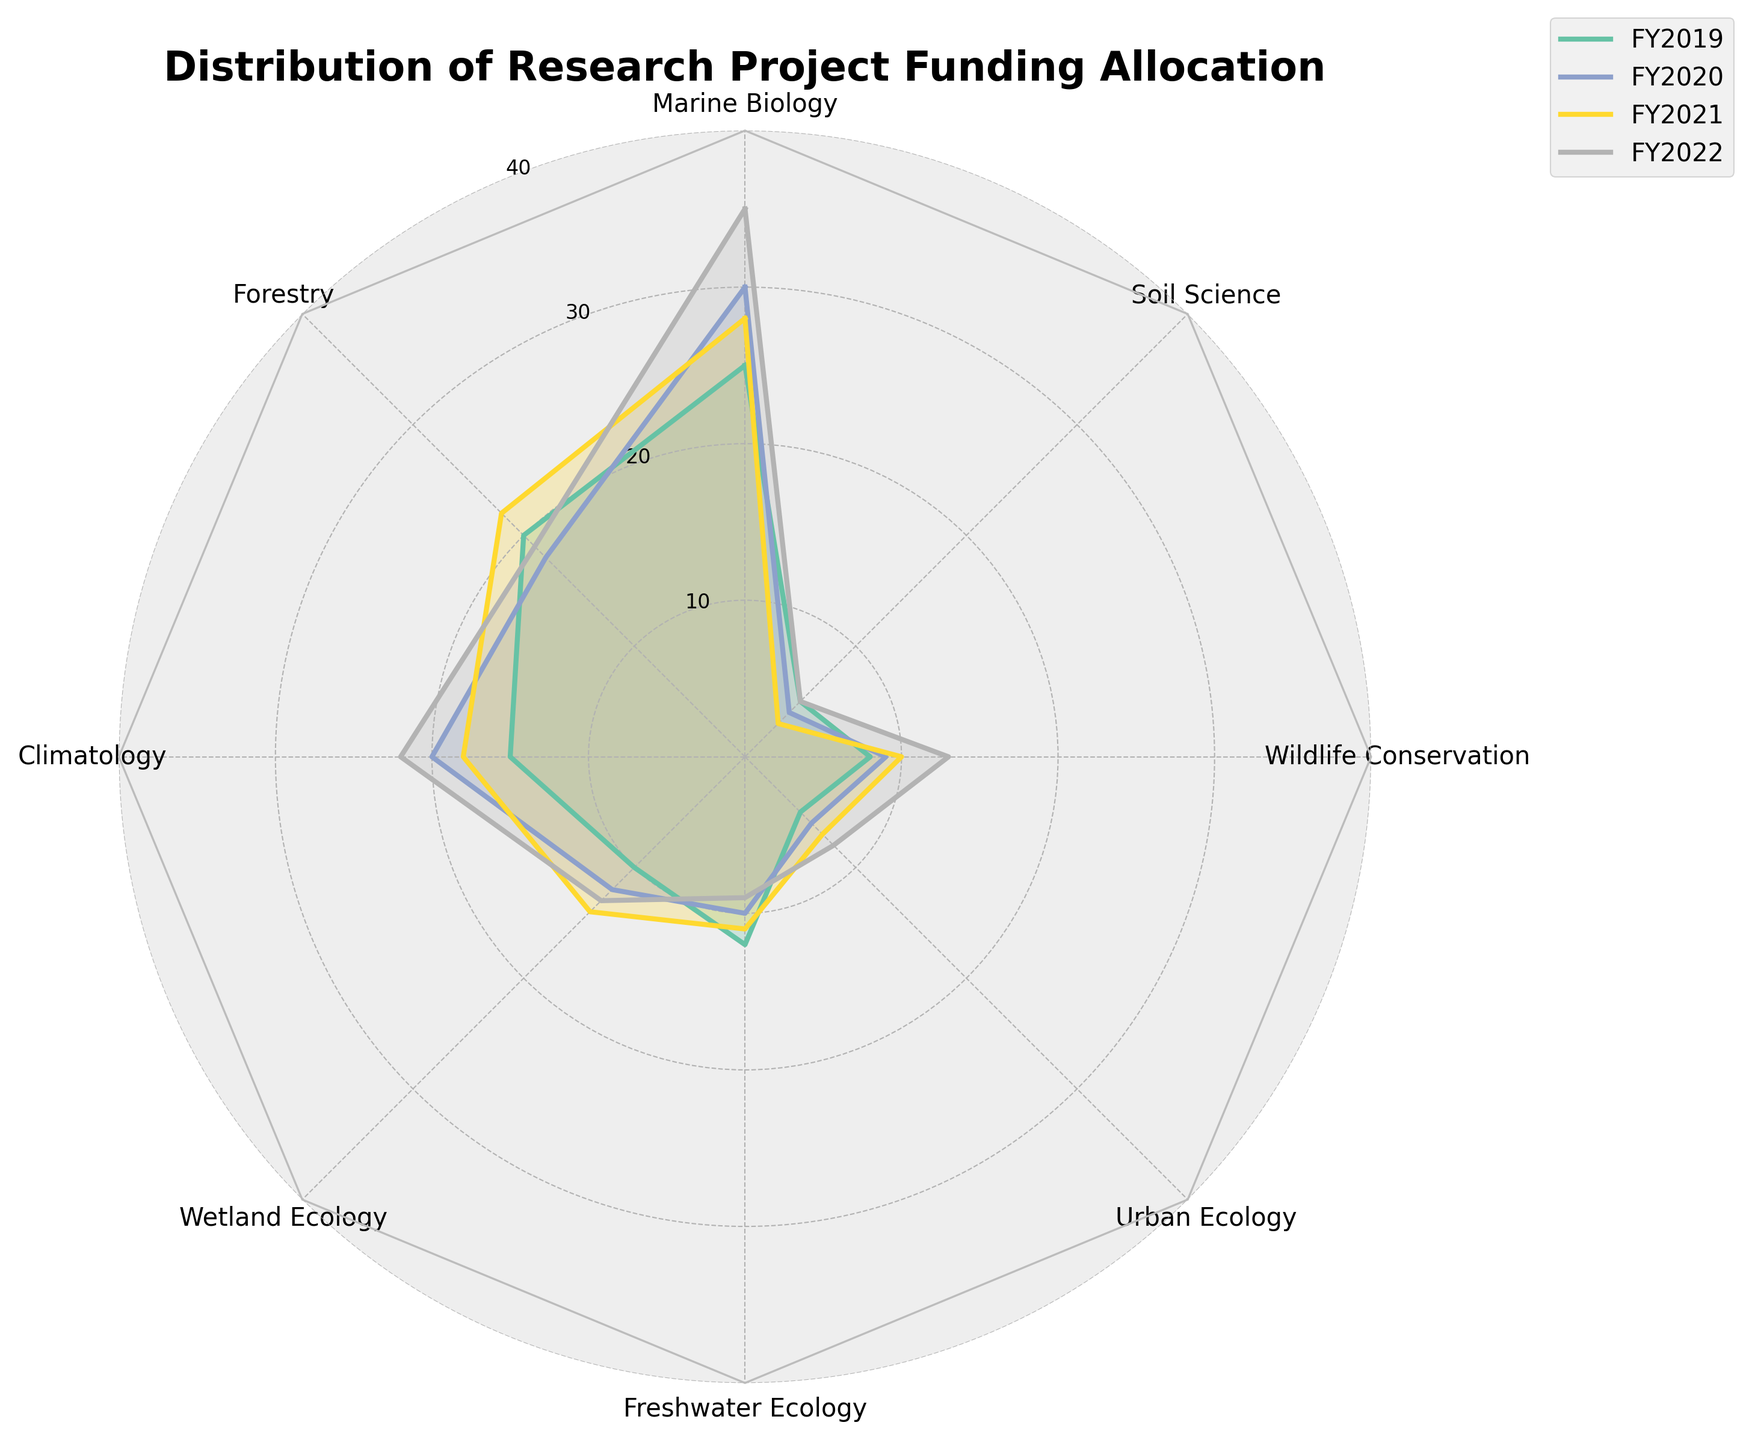Which subfield received the highest funding in FY2022? By examining the radar chart, we see that each subfield is represented by a different axis. The line corresponding to FY2022 indicates the funding distribution across subfields. Notably, the highest value on the FY2022 line is for Marine Biology.
Answer: Marine Biology Compare the funding trends for Marine Biology and Forestry over the years. Which subfield shows a more significant increase? To compare trends, we'll look at the values for both subfields over the specified years. Marine Biology increased from 25 to 35 units, a difference of 10 units. Forestry saw a change from 20 to 19 units, a decrease of 1 unit. Thus, Marine Biology shows a more significant increase.
Answer: Marine Biology What is the average funding for Climatology over the four years? To find the average, we sum the values for Climatology over the four years (15, 20, 18, 22) and divide by 4. The total sum is 75, so the average is 75/4, which equals 18.75.
Answer: 18.75 Which subfield had the least variation in funding from FY2019 to FY2022? To determine the least variation, we look at the difference between the highest and lowest values for each subfield over the years. Soil Science, changing from 3 to 5, has the smallest range of 2 units.
Answer: Soil Science How did the funding for Urban Ecology change from FY2019 to FY2022? By examining the radar chart, we see Urban Ecology's funding increase each year: FY2019 (5), FY2020 (6), FY2021 (7), and FY2022 (8). So, the funding progressively increased.
Answer: Increased Did any subfield have a consistent decrease in funding from FY2019 to FY2022? To identify consistent decreases, we examine each subfield's trend across the years. Soil Science showed a reduction from FY2019 (5) to FY2020 (4) to FY2021 (3) but returned to 5 in FY2022, hence no consistent decrease.
Answer: No Which subfield received exactly 20 units of funding in any year? By observing each year's data on the radar chart, we can spot that Forestry received exactly 20 units in FY2019, and Climatology received 20 units in FY2020.
Answer: Forestry and Climatology Is there any year where Freshwater Ecology received more funding than Wetland Ecology? By comparing the values, we observe that in all years, Wetland Ecology has higher values compared to Freshwater Ecology: FY2019 (10 vs. 12), FY2020 (12 vs. 10), FY2021 (14 vs. 11), and FY2022 (13 vs. 9). So, no year meets the criteria.
Answer: No What is the total funding received by Wildlife Conservation over the four years? We sum up the annual funding values for Wildlife Conservation: 8 (FY2019) + 9 (FY2020) + 10 (FY2021) + 13 (FY2022), resulting in a total of 40 units.
Answer: 40 Between which consecutive years did Climatology see the highest increase in funding? We analyze the changes for Climatology: FY2019 to FY2020 (+5 units), FY2020 to FY2021 (-2 units), and FY2021 to FY2022 (+4 units). The highest increase is from FY2019 to FY2020.
Answer: FY2019 to FY2020 